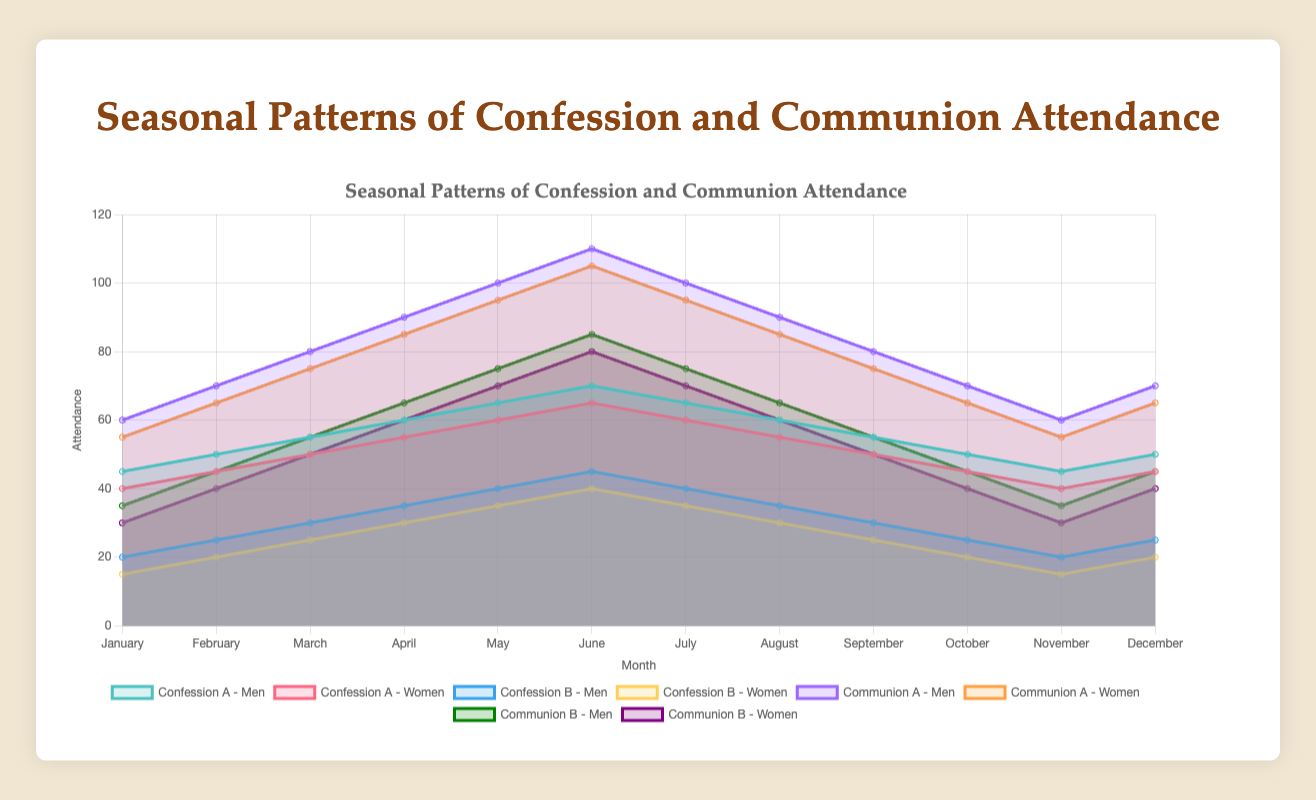What is the title of the figure? The title is displayed at the top of the figure and serves to inform viewers about its content. It is written in a larger font and centered alignment.
Answer: Seasonal Patterns of Confession and Communion Attendance Which month has the highest attendance for Confession A among men? To answer this question, find the peak value in the dataset for Confession A among men and note the corresponding month.
Answer: June During which month do women attend Confession B the most? We analyze the dataset for Confession B among women and identify the month with the maximum attendance.
Answer: June Compare the attendance in Communion A between men and women in April. Which gender has higher attendance? Look at the data points for Communion A in April for both men and women and compare the values.
Answer: Men What is the average attendance for Communion A among men over the year? Sum all the data points for Communion A among men and divide by the number of months (12).
Answer: 80 Which month shows the lowest attendance in Communion B for both men and women? Examine the datasets for Communion B for both men and women to find the month where attendance is least for both genders.
Answer: January How does the attendance for Confession A among women in June compare to that in September? Compare the data points for Confession A among women in June and September to see the difference.
Answer: Higher in June Are there any months where the attendance for Communion B is equal for both men and women? Check the datasets for Communion B for matching data points between men and women for any months.
Answer: No What can you infer about the seasonal pattern of Communion A among women from July to December? Review the trend in the data points for Communion A among women from July to December to infer any patterns or trends.
Answer: Generally decreases Which event has a more significant variation in attendance between men and women throughout the year: Confession or Communion? Assess the range of attendance values between the highest and lowest data points for both Confession and Communion for men and women to determine which shows more variation.
Answer: Communion 